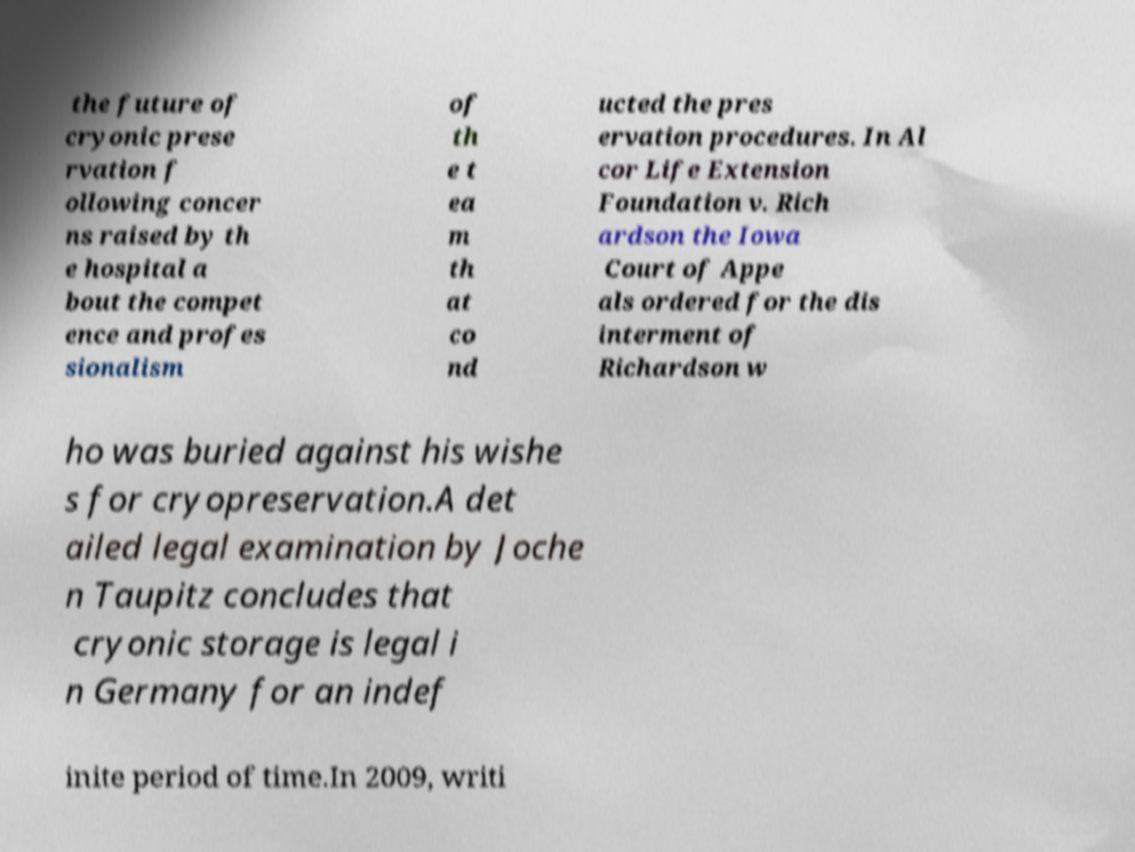For documentation purposes, I need the text within this image transcribed. Could you provide that? the future of cryonic prese rvation f ollowing concer ns raised by th e hospital a bout the compet ence and profes sionalism of th e t ea m th at co nd ucted the pres ervation procedures. In Al cor Life Extension Foundation v. Rich ardson the Iowa Court of Appe als ordered for the dis interment of Richardson w ho was buried against his wishe s for cryopreservation.A det ailed legal examination by Joche n Taupitz concludes that cryonic storage is legal i n Germany for an indef inite period of time.In 2009, writi 